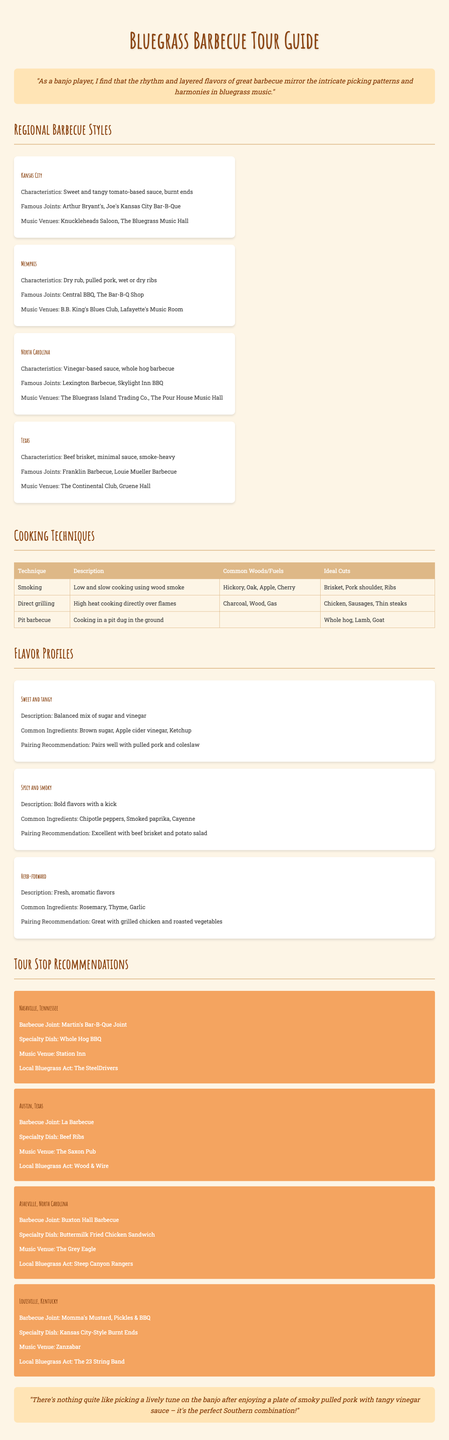What is the barbecue style characteristic of the Memphis region? The Memphis barbecue style is known for its dry rub, pulled pork, and wet or dry ribs.
Answer: Dry rub, pulled pork, wet or dry ribs Which city is home to the barbecue joint Franklin Barbecue? Franklin Barbecue is a famous joint located in the Texas barbecue region.
Answer: Austin, Texas What cooking technique involves low and slow cooking using wood smoke? This technique is essential for achieving the desired flavor and tenderness in barbecue.
Answer: Smoking What is the specialty dish at Martin's Bar-B-Que Joint? Martin's Bar-B-Que Joint specializes in a traditional Southern dish that is a staple in barbecue culture.
Answer: Whole Hog BBQ Which flavor profile is described as a balanced mix of sugar and vinegar? Understanding different flavor profiles helps in pairing barbecue with side dishes effectively.
Answer: Sweet and tangy Which local bluegrass act is associated with the music venue Zanzabar? Knowing local acts can enhance the performance experience during the tour.
Answer: The 23 String Band What is a common wood used in smoking barbecue? This wood is often preferred for imparting a robust flavor to smoked meats.
Answer: Hickory Which region is known for its vinegar-based sauce and whole hog barbecue? Identifying regional differences in barbecue styles is crucial for culinary exploration.
Answer: North Carolina 